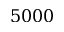<formula> <loc_0><loc_0><loc_500><loc_500>5 0 0 0</formula> 